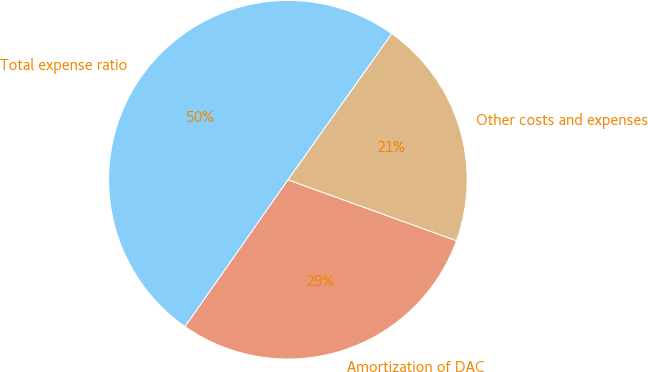<chart> <loc_0><loc_0><loc_500><loc_500><pie_chart><fcel>Amortization of DAC<fcel>Other costs and expenses<fcel>Total expense ratio<nl><fcel>29.21%<fcel>20.69%<fcel>50.1%<nl></chart> 